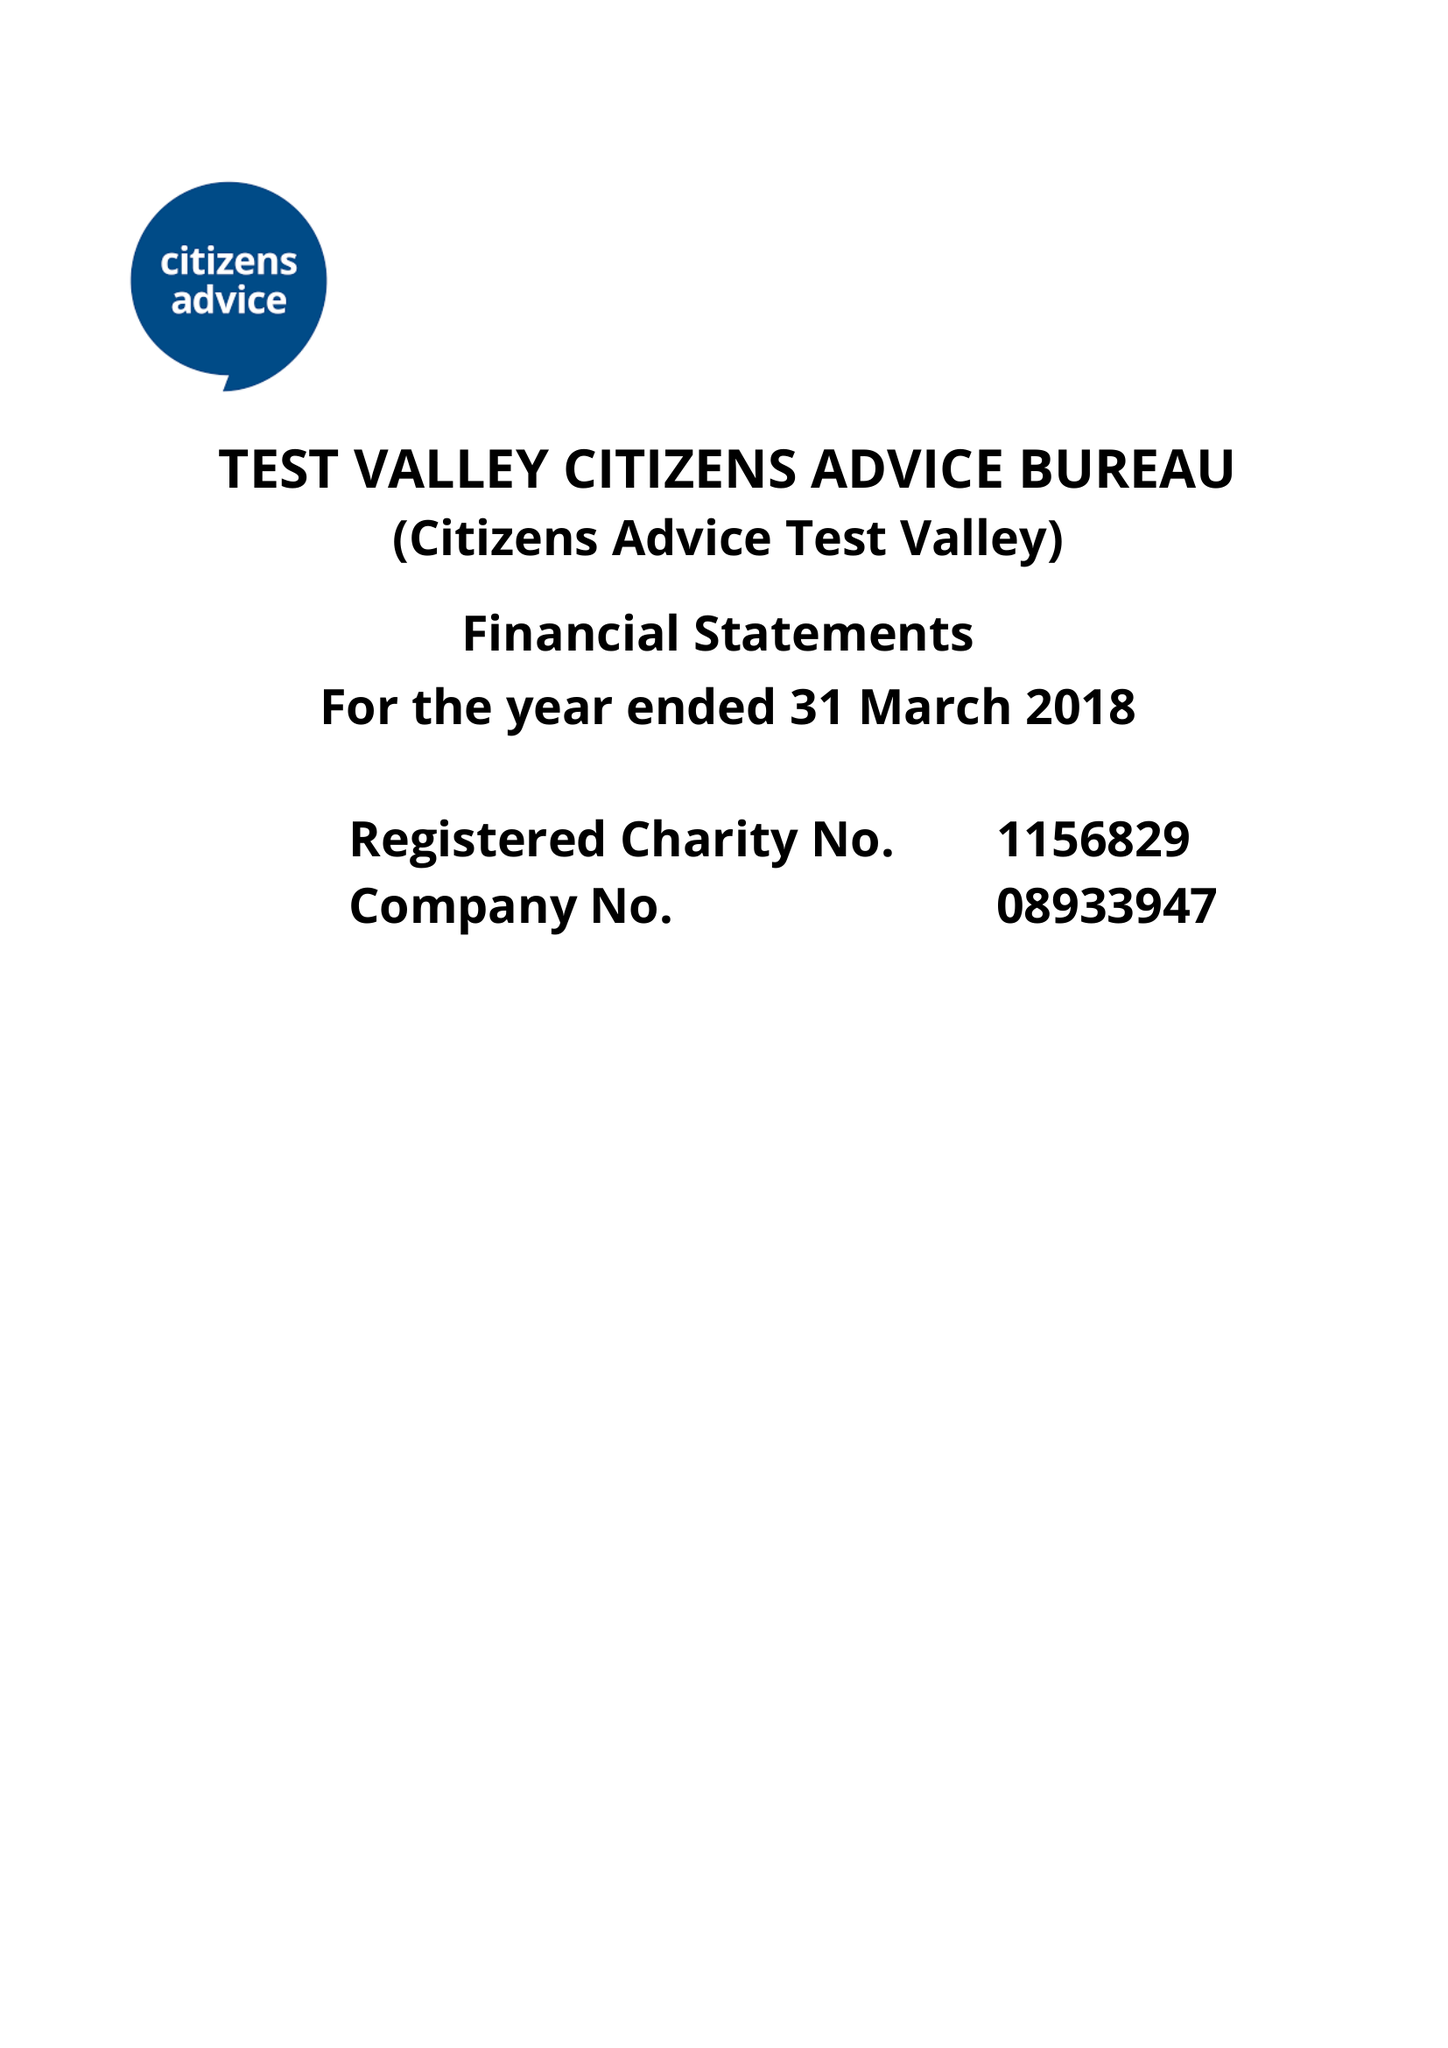What is the value for the charity_name?
Answer the question using a single word or phrase. Test Valley Citizens Advice Bureau 